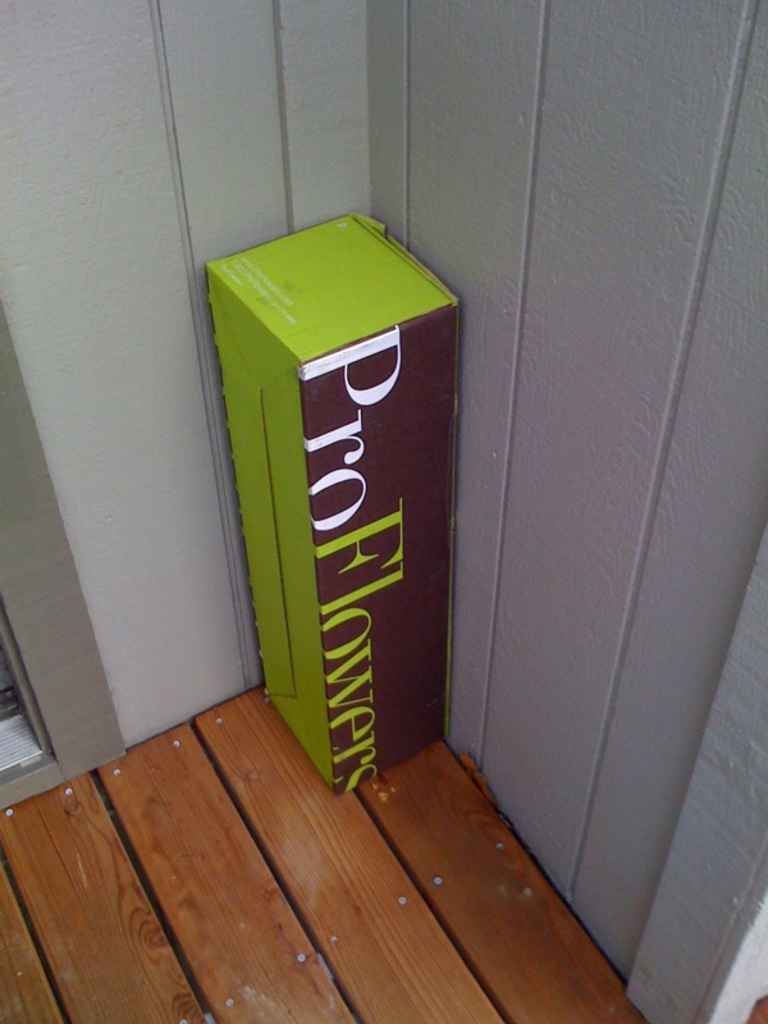What might be the likely content inside this ProFlowers box? Given the branding and typical business of ProFlowers, the box likely contains a floral arrangement or a bouquet. These could range from seasonal flowers to a custom bouquet meant for a special occasion such as a birthday, anniversary, or a 'just because' gift. The dimensions of the box suggest that the flowers inside could be tall and potentially accompanied by a vase. 